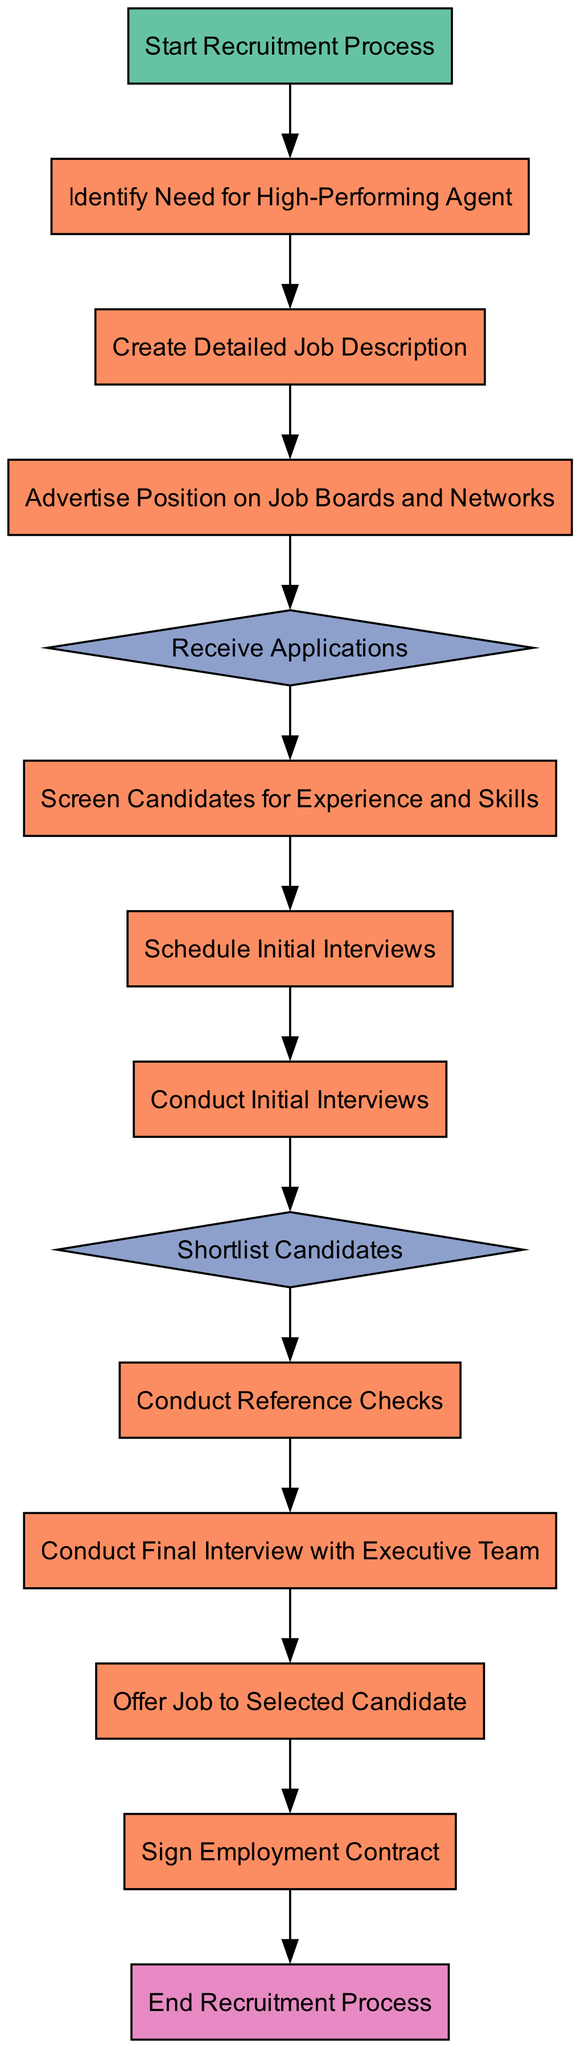What is the first step in the recruitment process? The first step in the recruitment process is represented by the "Start Recruitment Process" node, which initiates the flow of the diagram.
Answer: Start Recruitment Process How many process nodes are in the diagram? By reviewing the diagram, there are six process nodes that detail specific actions taken during recruitment.
Answer: Six What is the last step in the recruitment process? The last step is represented by the "End Recruitment Process" node, which marks the conclusion of the recruitment flow.
Answer: End Recruitment Process What happens after conducting initial interviews? After conducting initial interviews, the next step is to "Shortlist Candidates," determining which candidates proceed in the recruitment process.
Answer: Shortlist Candidates Which step involves checking candidates' backgrounds? The step that involves verifying candidates' backgrounds is "Conduct Reference Checks," which is a crucial part of the recruitment process.
Answer: Conduct Reference Checks What decision is made after receiving applications? After receiving applications, the next decision is to "Screen Candidates for Experience and Skills," determining which candidates meet the initial criteria.
Answer: Screen Candidates for Experience and Skills How many decision nodes are present in the diagram? There are two decision nodes in the diagram, which are used to make critical choices about candidates during the recruitment process.
Answer: Two What is required before offering a job to a selected candidate? Before offering a job, the process requires conducting a "Final Interview with Executive Team," ensuring the candidate's fit for the organization.
Answer: Final Interview with Executive Team What type of node is used for scheduling interviews? The node for scheduling interviews is a process node labeled "Schedule Initial Interviews," indicating that it is an action taken within the recruitment process.
Answer: Process Node 